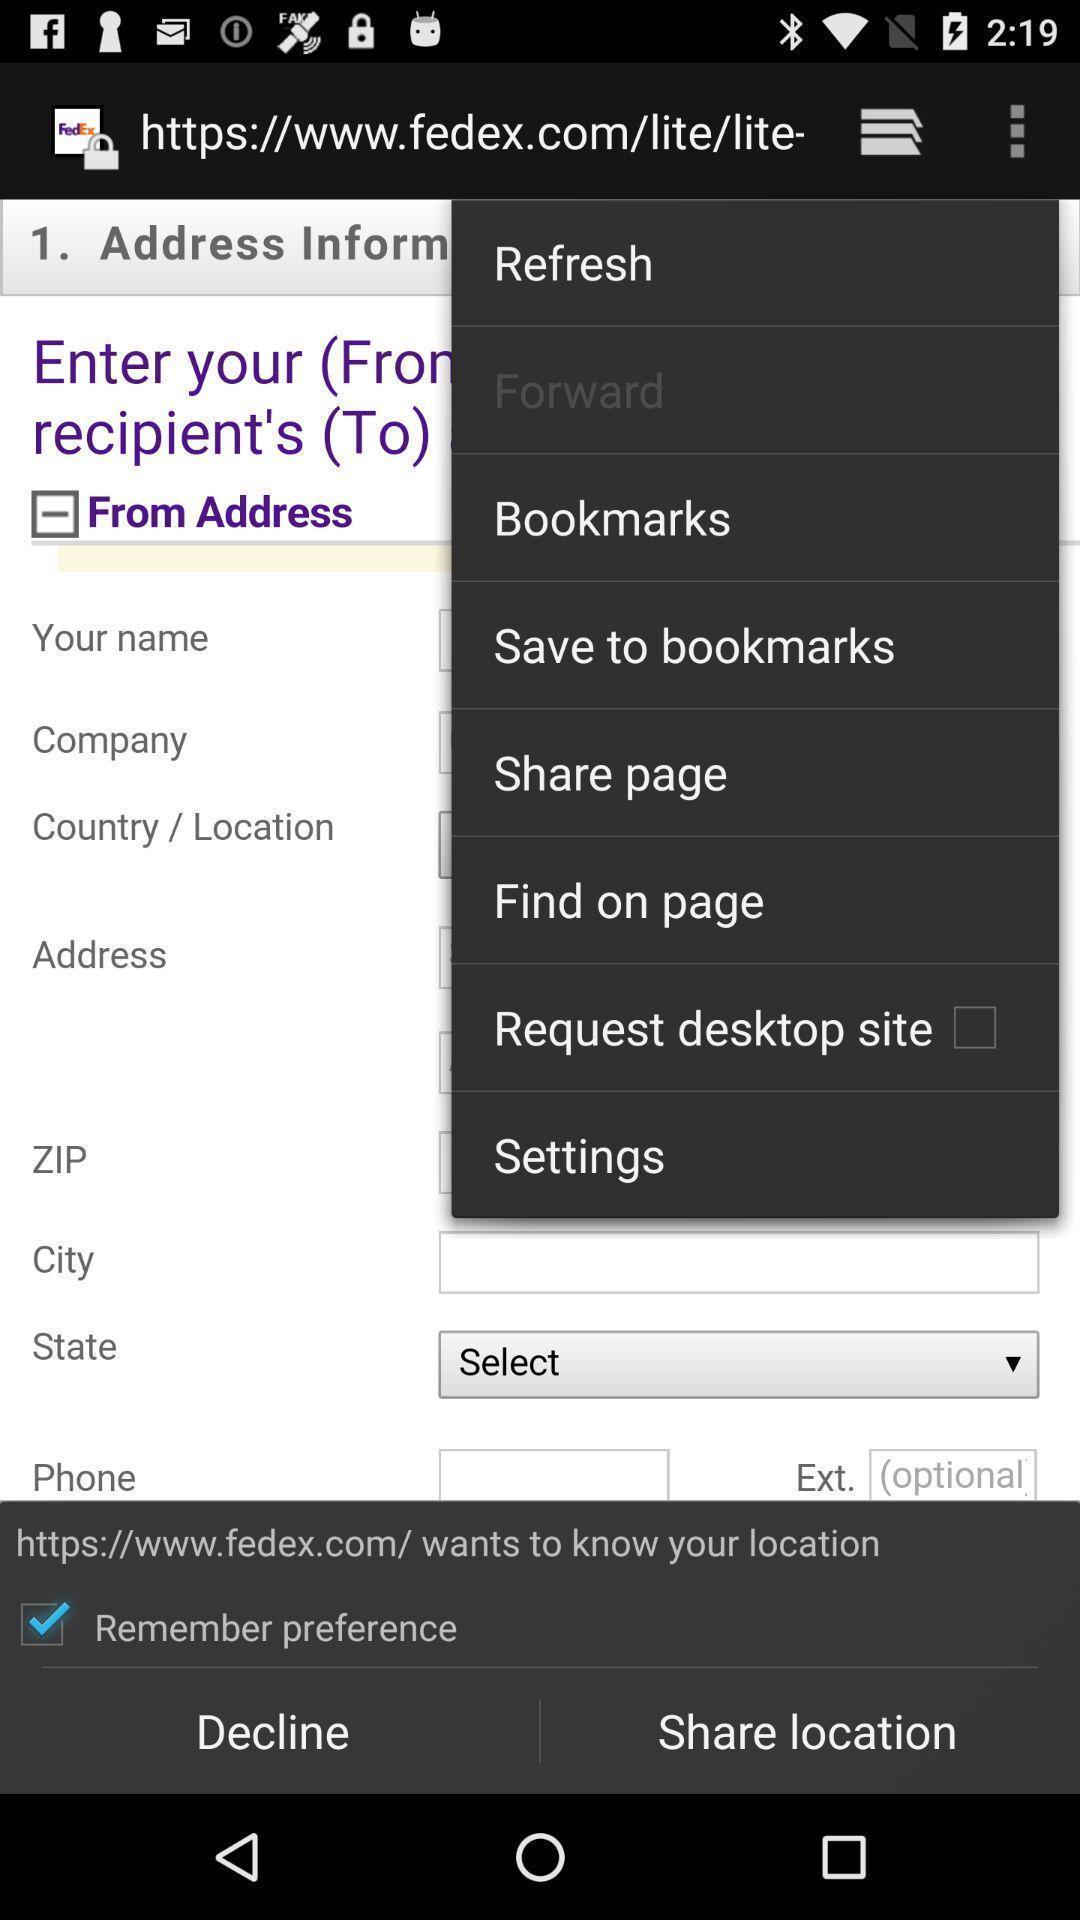What details can you identify in this image? Screen shows different options in browsing page. 